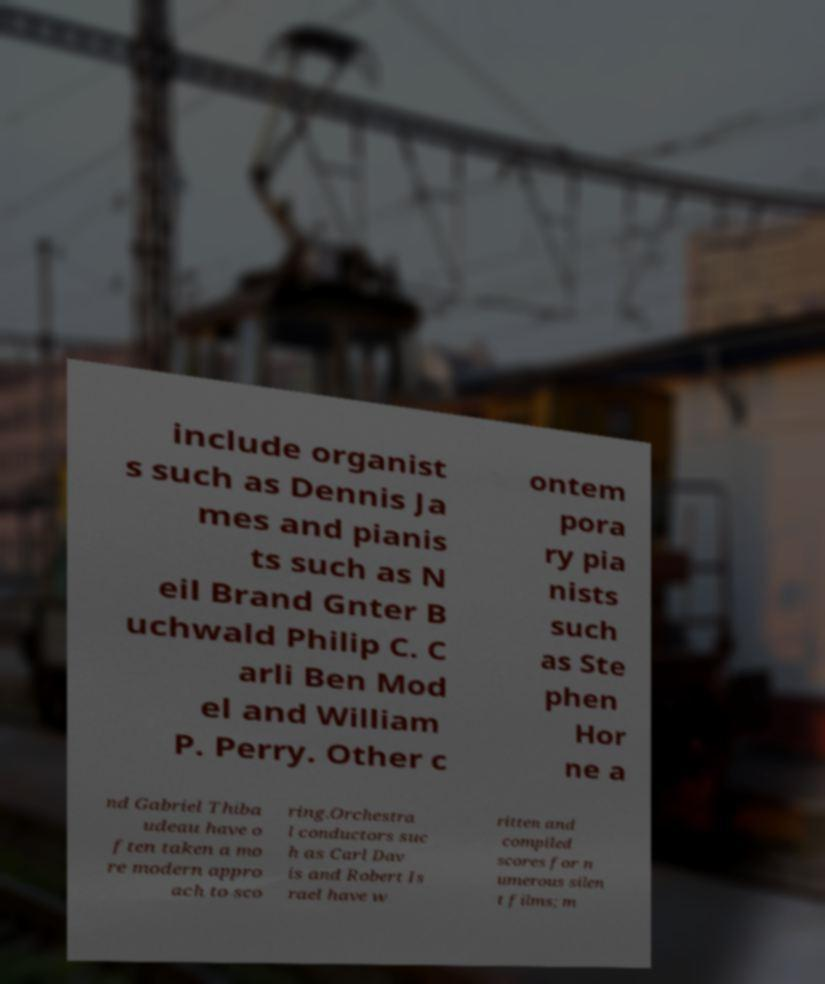Please read and relay the text visible in this image. What does it say? include organist s such as Dennis Ja mes and pianis ts such as N eil Brand Gnter B uchwald Philip C. C arli Ben Mod el and William P. Perry. Other c ontem pora ry pia nists such as Ste phen Hor ne a nd Gabriel Thiba udeau have o ften taken a mo re modern appro ach to sco ring.Orchestra l conductors suc h as Carl Dav is and Robert Is rael have w ritten and compiled scores for n umerous silen t films; m 